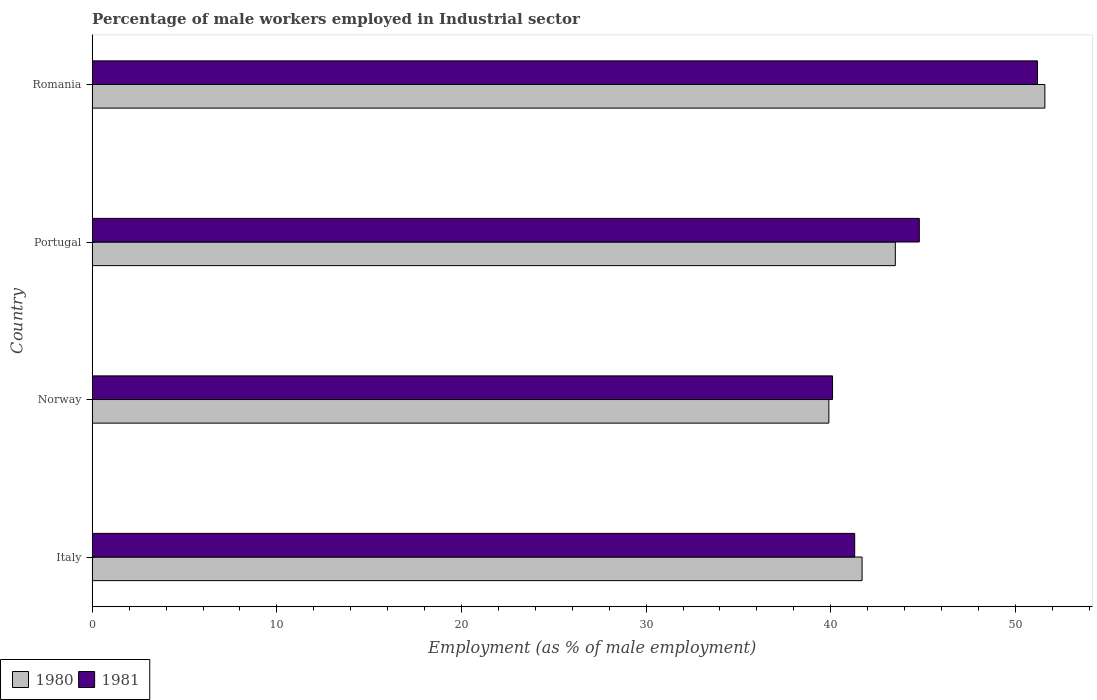Are the number of bars per tick equal to the number of legend labels?
Your answer should be compact. Yes. Are the number of bars on each tick of the Y-axis equal?
Offer a very short reply. Yes. How many bars are there on the 1st tick from the bottom?
Offer a terse response. 2. What is the label of the 4th group of bars from the top?
Give a very brief answer. Italy. What is the percentage of male workers employed in Industrial sector in 1981 in Norway?
Offer a very short reply. 40.1. Across all countries, what is the maximum percentage of male workers employed in Industrial sector in 1981?
Make the answer very short. 51.2. Across all countries, what is the minimum percentage of male workers employed in Industrial sector in 1981?
Make the answer very short. 40.1. In which country was the percentage of male workers employed in Industrial sector in 1980 maximum?
Your answer should be very brief. Romania. What is the total percentage of male workers employed in Industrial sector in 1980 in the graph?
Offer a terse response. 176.7. What is the difference between the percentage of male workers employed in Industrial sector in 1980 in Norway and that in Portugal?
Your answer should be very brief. -3.6. What is the difference between the percentage of male workers employed in Industrial sector in 1980 in Portugal and the percentage of male workers employed in Industrial sector in 1981 in Italy?
Offer a very short reply. 2.2. What is the average percentage of male workers employed in Industrial sector in 1981 per country?
Provide a short and direct response. 44.35. What is the difference between the percentage of male workers employed in Industrial sector in 1980 and percentage of male workers employed in Industrial sector in 1981 in Italy?
Your answer should be very brief. 0.4. In how many countries, is the percentage of male workers employed in Industrial sector in 1981 greater than 26 %?
Your response must be concise. 4. What is the ratio of the percentage of male workers employed in Industrial sector in 1980 in Italy to that in Norway?
Ensure brevity in your answer.  1.05. Is the difference between the percentage of male workers employed in Industrial sector in 1980 in Norway and Romania greater than the difference between the percentage of male workers employed in Industrial sector in 1981 in Norway and Romania?
Your response must be concise. No. What is the difference between the highest and the second highest percentage of male workers employed in Industrial sector in 1980?
Offer a terse response. 8.1. What is the difference between the highest and the lowest percentage of male workers employed in Industrial sector in 1981?
Give a very brief answer. 11.1. In how many countries, is the percentage of male workers employed in Industrial sector in 1980 greater than the average percentage of male workers employed in Industrial sector in 1980 taken over all countries?
Offer a terse response. 1. What does the 1st bar from the bottom in Romania represents?
Offer a very short reply. 1980. How many countries are there in the graph?
Your response must be concise. 4. What is the difference between two consecutive major ticks on the X-axis?
Your answer should be very brief. 10. What is the title of the graph?
Make the answer very short. Percentage of male workers employed in Industrial sector. Does "1977" appear as one of the legend labels in the graph?
Make the answer very short. No. What is the label or title of the X-axis?
Ensure brevity in your answer.  Employment (as % of male employment). What is the label or title of the Y-axis?
Provide a succinct answer. Country. What is the Employment (as % of male employment) of 1980 in Italy?
Keep it short and to the point. 41.7. What is the Employment (as % of male employment) of 1981 in Italy?
Your response must be concise. 41.3. What is the Employment (as % of male employment) in 1980 in Norway?
Make the answer very short. 39.9. What is the Employment (as % of male employment) of 1981 in Norway?
Offer a very short reply. 40.1. What is the Employment (as % of male employment) in 1980 in Portugal?
Ensure brevity in your answer.  43.5. What is the Employment (as % of male employment) of 1981 in Portugal?
Provide a short and direct response. 44.8. What is the Employment (as % of male employment) in 1980 in Romania?
Give a very brief answer. 51.6. What is the Employment (as % of male employment) in 1981 in Romania?
Provide a succinct answer. 51.2. Across all countries, what is the maximum Employment (as % of male employment) in 1980?
Keep it short and to the point. 51.6. Across all countries, what is the maximum Employment (as % of male employment) of 1981?
Keep it short and to the point. 51.2. Across all countries, what is the minimum Employment (as % of male employment) of 1980?
Keep it short and to the point. 39.9. Across all countries, what is the minimum Employment (as % of male employment) in 1981?
Your answer should be very brief. 40.1. What is the total Employment (as % of male employment) in 1980 in the graph?
Provide a succinct answer. 176.7. What is the total Employment (as % of male employment) in 1981 in the graph?
Ensure brevity in your answer.  177.4. What is the difference between the Employment (as % of male employment) of 1980 in Italy and that in Portugal?
Ensure brevity in your answer.  -1.8. What is the difference between the Employment (as % of male employment) in 1981 in Italy and that in Romania?
Keep it short and to the point. -9.9. What is the difference between the Employment (as % of male employment) of 1981 in Norway and that in Romania?
Offer a terse response. -11.1. What is the difference between the Employment (as % of male employment) of 1980 in Portugal and that in Romania?
Make the answer very short. -8.1. What is the difference between the Employment (as % of male employment) of 1981 in Portugal and that in Romania?
Provide a succinct answer. -6.4. What is the difference between the Employment (as % of male employment) of 1980 in Italy and the Employment (as % of male employment) of 1981 in Portugal?
Keep it short and to the point. -3.1. What is the average Employment (as % of male employment) in 1980 per country?
Your answer should be very brief. 44.17. What is the average Employment (as % of male employment) in 1981 per country?
Provide a succinct answer. 44.35. What is the difference between the Employment (as % of male employment) of 1980 and Employment (as % of male employment) of 1981 in Romania?
Ensure brevity in your answer.  0.4. What is the ratio of the Employment (as % of male employment) of 1980 in Italy to that in Norway?
Make the answer very short. 1.05. What is the ratio of the Employment (as % of male employment) in 1981 in Italy to that in Norway?
Offer a terse response. 1.03. What is the ratio of the Employment (as % of male employment) in 1980 in Italy to that in Portugal?
Give a very brief answer. 0.96. What is the ratio of the Employment (as % of male employment) of 1981 in Italy to that in Portugal?
Offer a very short reply. 0.92. What is the ratio of the Employment (as % of male employment) of 1980 in Italy to that in Romania?
Your response must be concise. 0.81. What is the ratio of the Employment (as % of male employment) in 1981 in Italy to that in Romania?
Give a very brief answer. 0.81. What is the ratio of the Employment (as % of male employment) of 1980 in Norway to that in Portugal?
Your answer should be very brief. 0.92. What is the ratio of the Employment (as % of male employment) in 1981 in Norway to that in Portugal?
Offer a terse response. 0.9. What is the ratio of the Employment (as % of male employment) in 1980 in Norway to that in Romania?
Your answer should be compact. 0.77. What is the ratio of the Employment (as % of male employment) of 1981 in Norway to that in Romania?
Provide a succinct answer. 0.78. What is the ratio of the Employment (as % of male employment) of 1980 in Portugal to that in Romania?
Your answer should be compact. 0.84. What is the ratio of the Employment (as % of male employment) in 1981 in Portugal to that in Romania?
Offer a very short reply. 0.88. What is the difference between the highest and the lowest Employment (as % of male employment) of 1980?
Offer a terse response. 11.7. What is the difference between the highest and the lowest Employment (as % of male employment) of 1981?
Give a very brief answer. 11.1. 